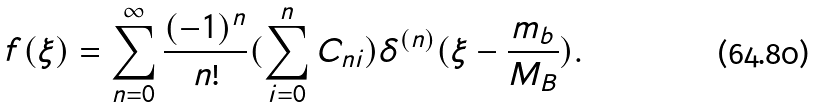<formula> <loc_0><loc_0><loc_500><loc_500>f ( \xi ) = \sum _ { n = 0 } ^ { \infty } \frac { ( - 1 ) ^ { n } } { n ! } ( \sum _ { i = 0 } ^ { n } C _ { n i } ) \delta ^ { ( n ) } ( \xi - \frac { m _ { b } } { M _ { B } } ) .</formula> 